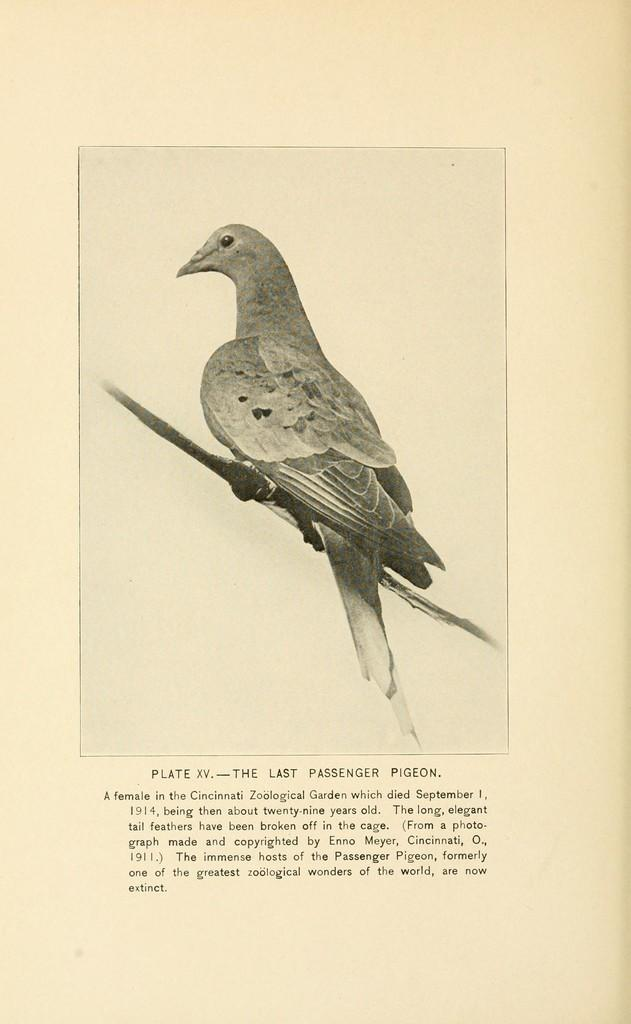What is the main subject in the center of the image? There is a paper in the center of the image. What is depicted on the paper? A bird is depicted on the paper. What is the bird resting on? The bird is on some object. What can be found at the bottom of the image? There is text at the bottom of the image. How many bears can be seen playing with the bird on the paper in the image? There are no bears present in the image; it only features a bird on a paper. 